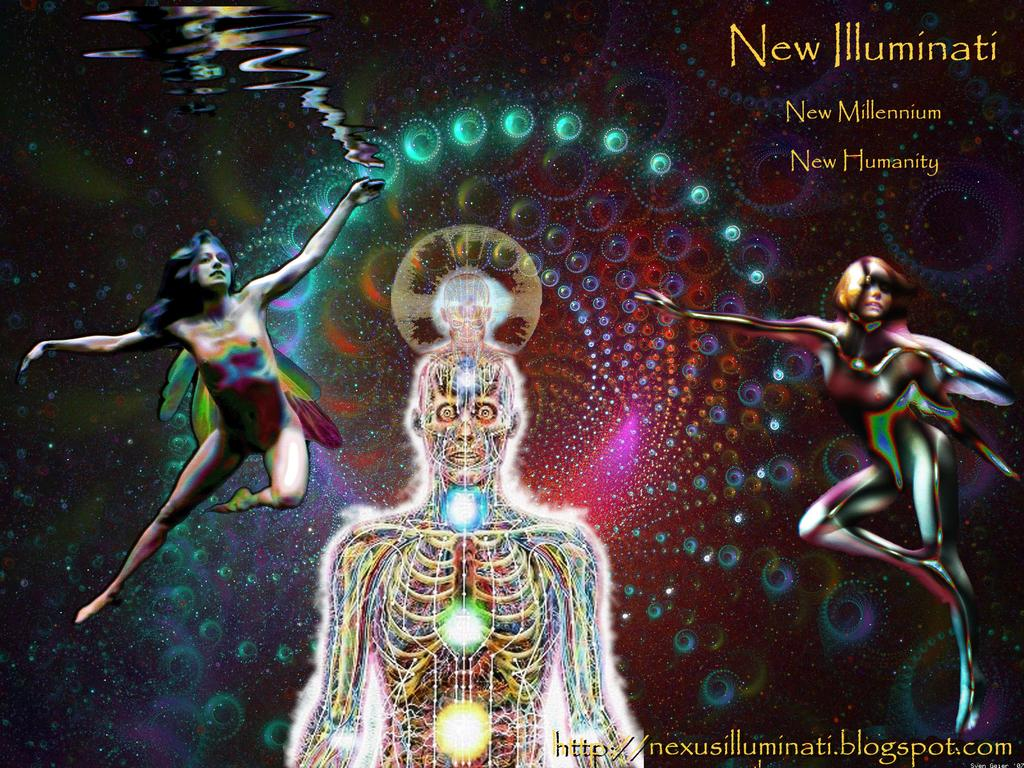<image>
Describe the image concisely. The artwork has human figures and the words New Illuminati, New Millenium, and New Humanity. 